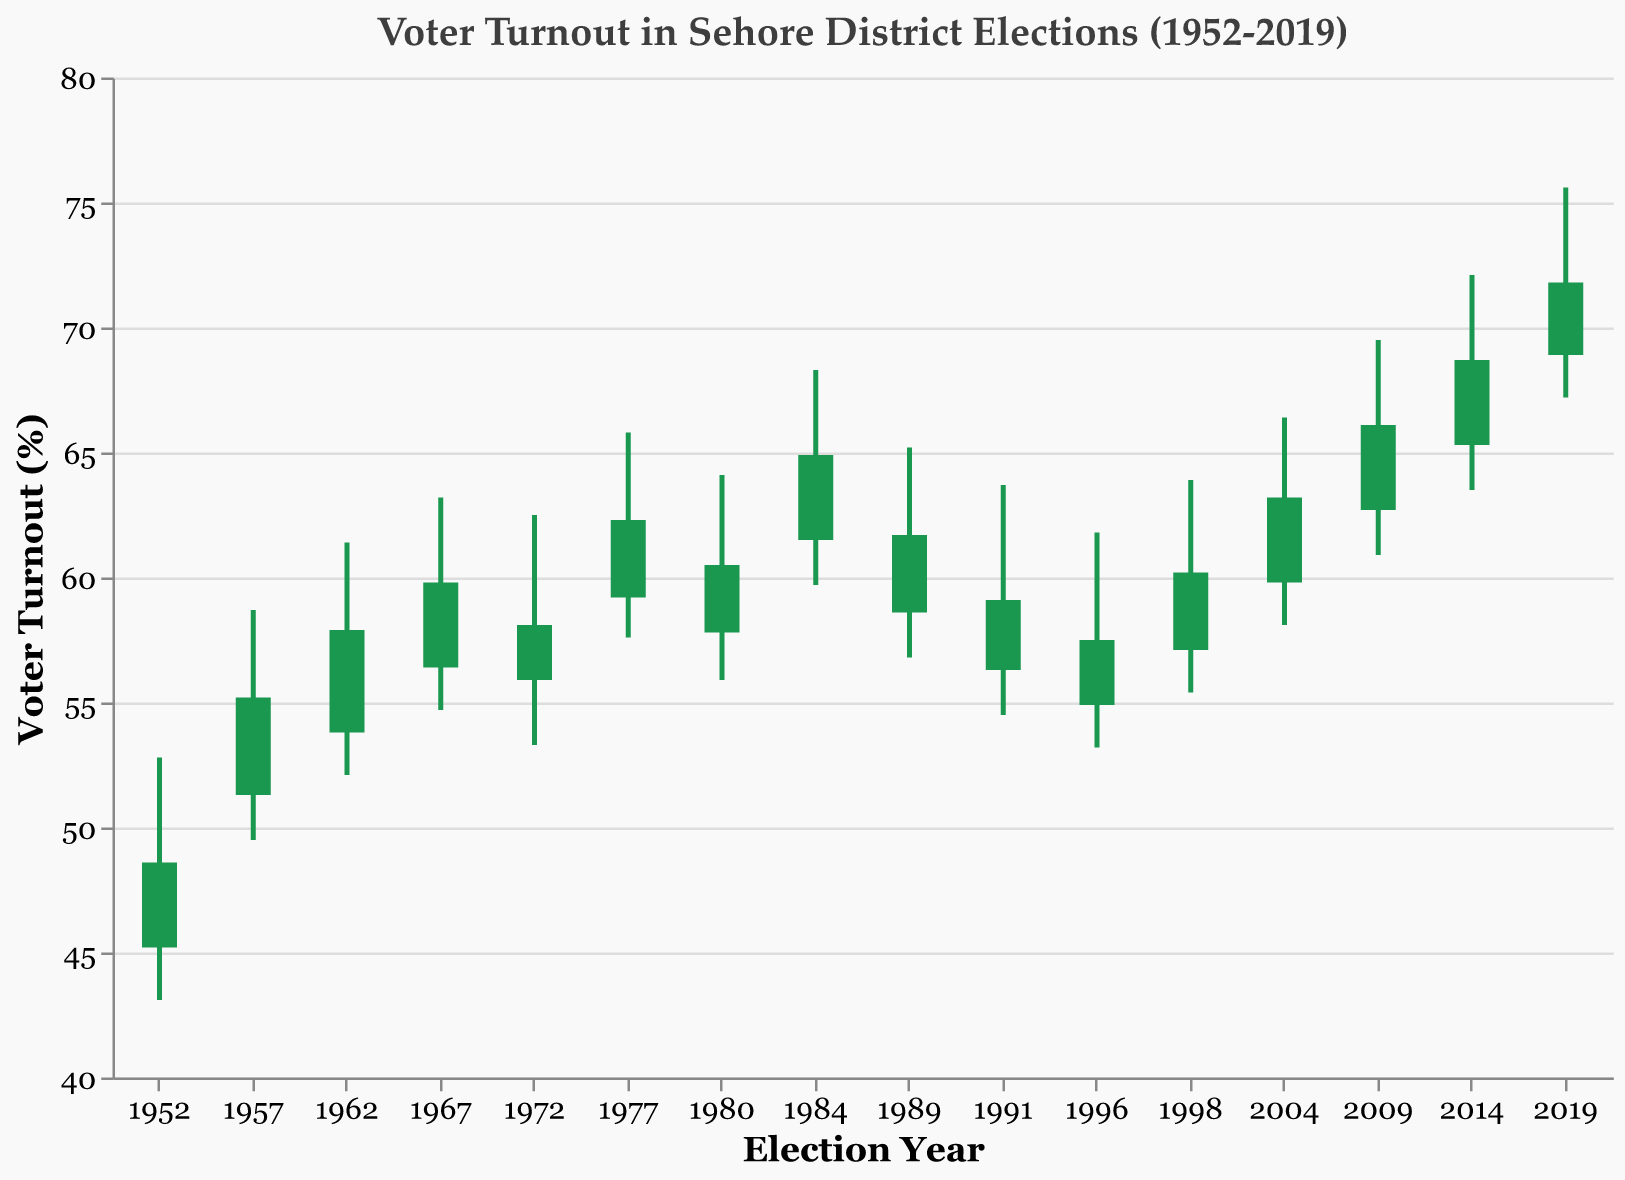What is the highest voter turnout percentage in the given years? The highest turnout percentage is shown by the "High" value in the dataset. By looking at the "High" column, the highest value is 75.6 in the year 2019.
Answer: 75.6% What was the voter turnout percentage at the end of the 1962 election? The "Close" value represents the voter turnout percentage at the end of the election. For the year 1962, the "Close" value is 57.9.
Answer: 57.9% Which election year had the lowest recorded voter turnout? The lowest recorded voter turnout is indicated by the "Low" value. By reviewing the "Low" column, the lowest value is 43.1 in the year 1952.
Answer: 43.1% Compare the voter turnout percentage at the beginning of 1977 and at the end of the same year. Which was higher? The "Open" value represents the beginning and the "Close" value represents the end. For the year 1977, the "Open" value is 59.2 and the "Close" value is 62.3. 62.3 is higher.
Answer: Close (62.3%) Which election year saw the greatest increase in voter turnout percentage from beginning to end? To find the greatest increase, subtract the “Open” value from the “Close” value for each year and compare the differences. The year 1984 had the greatest increase from 61.5 to 64.9, a difference of 3.4%.
Answer: 1984 (3.4%) What is the average voter turnout percentage at the beginning of the elections from 1952 to 1972? The "Open" values for the years 1952, 1957, 1962, 1967, and 1972 are 45.2, 51.3, 53.8, 56.4, and 55.9, respectively. The sum of these values is 262.6. The average is 262.6 / 5 = 52.52.
Answer: 52.52% How does the voter turnout at the beginning of the 2009 election compare to the end of the 1998 election? The "Open" value for 2009 is 62.7, and the "Close" value for 1998 is 60.2. Since 62.7 is greater than 60.2, the turnout at the beginning of 2009 is higher.
Answer: 62.7 is higher What trend can be observed from the voter turnout percentages between 2004 and 2014? Observing the "Close" values for 2004, 2009, and 2014, they are 63.2, 66.1, and 68.7 respectively. This shows an increasing trend in voter turnout percentages over these years.
Answer: Increasing trend What was the range of voter turnout percentages during the 2019 election? The range is calculated by subtracting the “Low” value from the “High” value for the year 2019. The values are 67.2 (Low) and 75.6 (High). The range is 75.6 - 67.2 = 8.4.
Answer: 8.4 In which decade did the voter turnout consistently exceed 60%? Reviewing the "Close" values for each decade, consistent values over 60% were observed from 1977 to 2014, except in the 1990s where two elections (1991 and 1996) have "Close" values below 60%. Thus, the consistent decade of turnout exceeding 60% is the 2000s (2004, 2009, 2014).
Answer: 2000s 